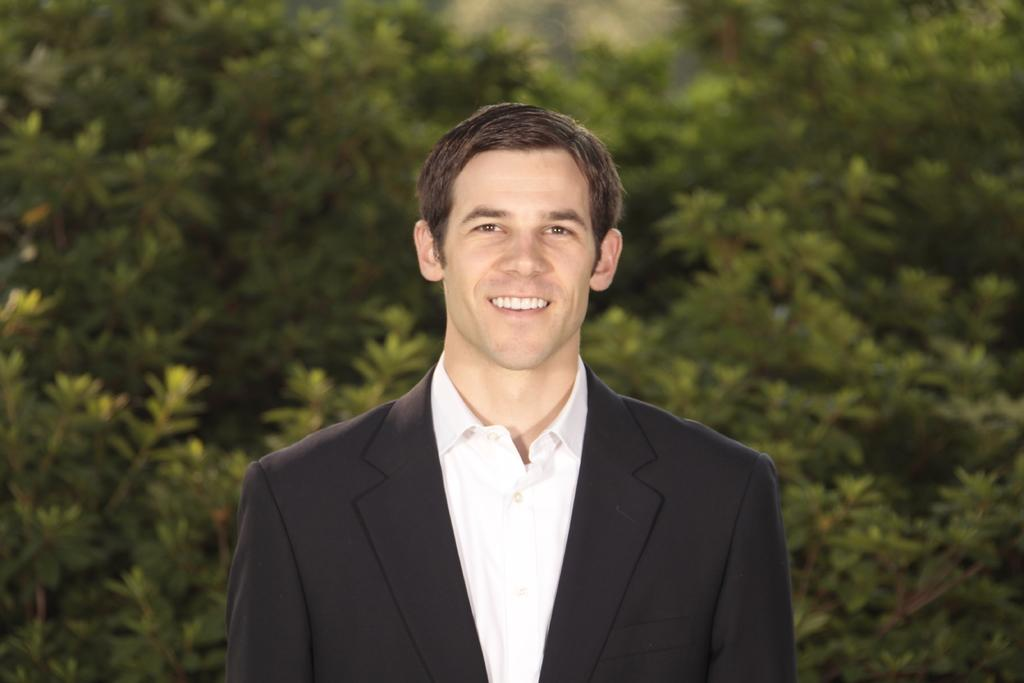Who is present in the image? There is a man in the image. What is the man doing in the image? The man is standing in the image. What is the man wearing in the image? The man is wearing a black color blazer and a white shirt in the image. What can be seen in the background of the image? There are plants visible in the background of the image. How many kittens are playing on the dock in the image? There are no kittens or docks present in the image. Are the man's brothers also visible in the image? The provided facts do not mention any brothers, so we cannot determine if they are present in the image. 